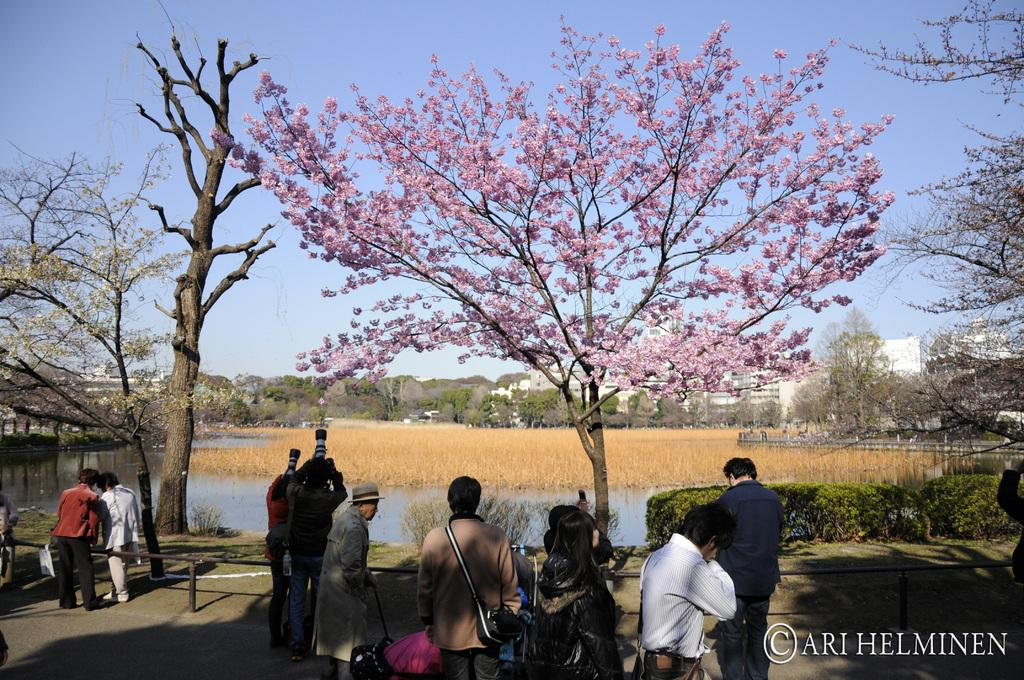What is happening in the center of the image? There are people standing in the center of the image. What natural element can be seen in the image? There is a tree in the image. What can be seen in the background of the image? There are buildings, trees, grass, and water visible in the background of the image. What type of heart can be seen beating in the image? There is no heart visible in the image. How many lizards are present in the image? There are no lizards present in the image. 